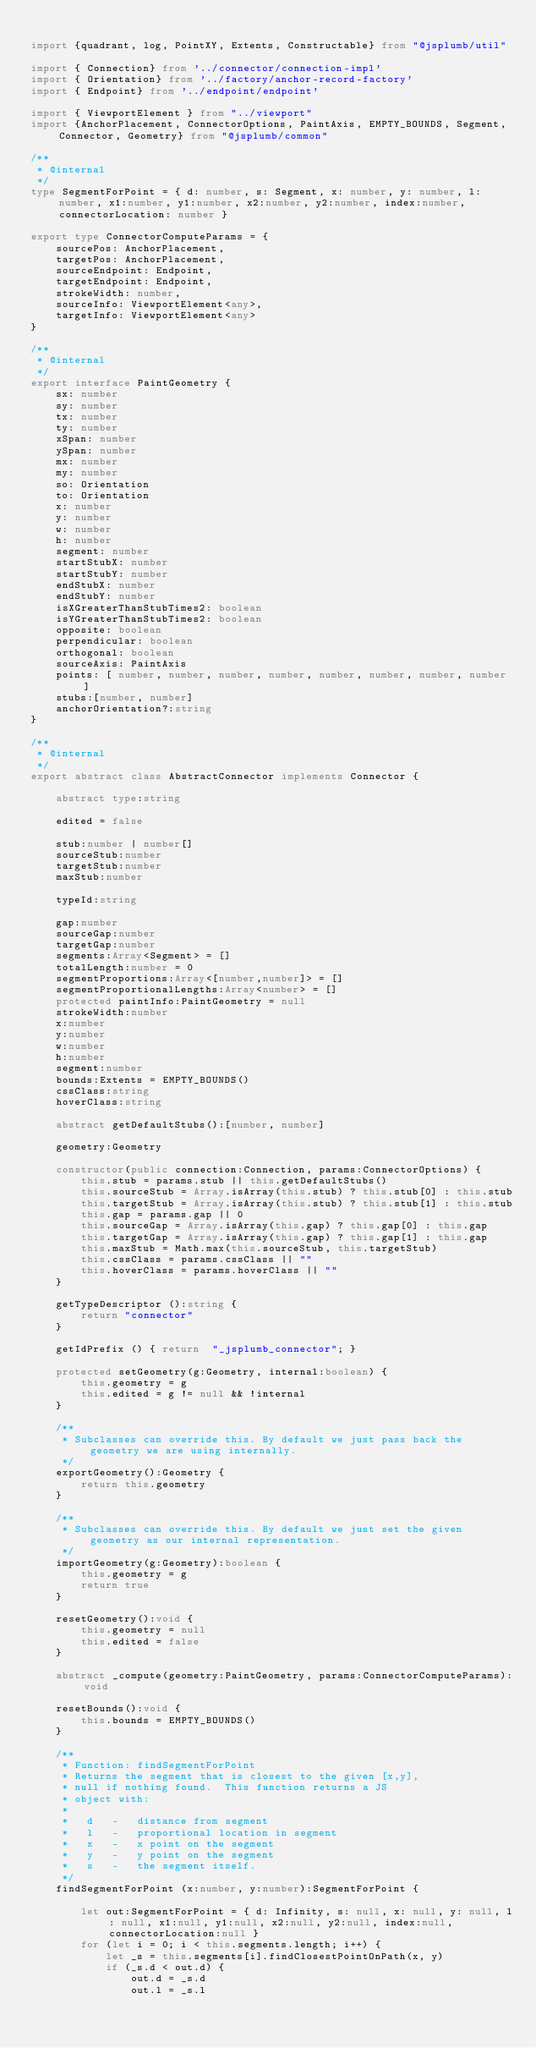<code> <loc_0><loc_0><loc_500><loc_500><_TypeScript_>
import {quadrant, log, PointXY, Extents, Constructable} from "@jsplumb/util"

import { Connection} from '../connector/connection-impl'
import { Orientation} from '../factory/anchor-record-factory'
import { Endpoint} from '../endpoint/endpoint'

import { ViewportElement } from "../viewport"
import {AnchorPlacement, ConnectorOptions, PaintAxis, EMPTY_BOUNDS, Segment, Connector, Geometry} from "@jsplumb/common"

/**
 * @internal
 */
type SegmentForPoint = { d: number, s: Segment, x: number, y: number, l: number, x1:number, y1:number, x2:number, y2:number, index:number, connectorLocation: number }

export type ConnectorComputeParams = {
    sourcePos: AnchorPlacement,
    targetPos: AnchorPlacement,
    sourceEndpoint: Endpoint,
    targetEndpoint: Endpoint,
    strokeWidth: number,
    sourceInfo: ViewportElement<any>,
    targetInfo: ViewportElement<any>
}

/**
 * @internal
 */
export interface PaintGeometry {
    sx: number
    sy: number
    tx: number
    ty: number
    xSpan: number
    ySpan: number
    mx: number
    my: number
    so: Orientation
    to: Orientation
    x: number
    y: number
    w: number
    h: number
    segment: number
    startStubX: number
    startStubY: number
    endStubX: number
    endStubY: number
    isXGreaterThanStubTimes2: boolean
    isYGreaterThanStubTimes2: boolean
    opposite: boolean
    perpendicular: boolean
    orthogonal: boolean
    sourceAxis: PaintAxis
    points: [ number, number, number, number, number, number, number, number ]
    stubs:[number, number]
    anchorOrientation?:string
}

/**
 * @internal
 */
export abstract class AbstractConnector implements Connector {

    abstract type:string

    edited = false

    stub:number | number[]
    sourceStub:number
    targetStub:number
    maxStub:number

    typeId:string

    gap:number
    sourceGap:number
    targetGap:number
    segments:Array<Segment> = []
    totalLength:number = 0
    segmentProportions:Array<[number,number]> = []
    segmentProportionalLengths:Array<number> = []
    protected paintInfo:PaintGeometry = null
    strokeWidth:number
    x:number
    y:number
    w:number
    h:number
    segment:number
    bounds:Extents = EMPTY_BOUNDS()
    cssClass:string
    hoverClass:string

    abstract getDefaultStubs():[number, number]

    geometry:Geometry

    constructor(public connection:Connection, params:ConnectorOptions) {
        this.stub = params.stub || this.getDefaultStubs()
        this.sourceStub = Array.isArray(this.stub) ? this.stub[0] : this.stub
        this.targetStub = Array.isArray(this.stub) ? this.stub[1] : this.stub
        this.gap = params.gap || 0
        this.sourceGap = Array.isArray(this.gap) ? this.gap[0] : this.gap
        this.targetGap = Array.isArray(this.gap) ? this.gap[1] : this.gap
        this.maxStub = Math.max(this.sourceStub, this.targetStub)
        this.cssClass = params.cssClass || ""
        this.hoverClass = params.hoverClass || ""
    }

    getTypeDescriptor ():string {
        return "connector"
    }
    
    getIdPrefix () { return  "_jsplumb_connector"; }

    protected setGeometry(g:Geometry, internal:boolean) {
        this.geometry = g
        this.edited = g != null && !internal
    }

    /**
     * Subclasses can override this. By default we just pass back the geometry we are using internally.
     */
    exportGeometry():Geometry {
        return this.geometry
    }

    /**
     * Subclasses can override this. By default we just set the given geometry as our internal representation.
     */
    importGeometry(g:Geometry):boolean {
        this.geometry = g
        return true
    }

    resetGeometry():void {
        this.geometry = null
        this.edited = false
    }

    abstract _compute(geometry:PaintGeometry, params:ConnectorComputeParams):void

    resetBounds():void {
        this.bounds = EMPTY_BOUNDS()
    }

    /**
     * Function: findSegmentForPoint
     * Returns the segment that is closest to the given [x,y],
     * null if nothing found.  This function returns a JS
     * object with:
     *
     *   d   -   distance from segment
     *   l   -   proportional location in segment
     *   x   -   x point on the segment
     *   y   -   y point on the segment
     *   s   -   the segment itself.
     */
    findSegmentForPoint (x:number, y:number):SegmentForPoint {

        let out:SegmentForPoint = { d: Infinity, s: null, x: null, y: null, l: null, x1:null, y1:null, x2:null, y2:null, index:null, connectorLocation:null }
        for (let i = 0; i < this.segments.length; i++) {
            let _s = this.segments[i].findClosestPointOnPath(x, y)
            if (_s.d < out.d) {
                out.d = _s.d
                out.l = _s.l</code> 